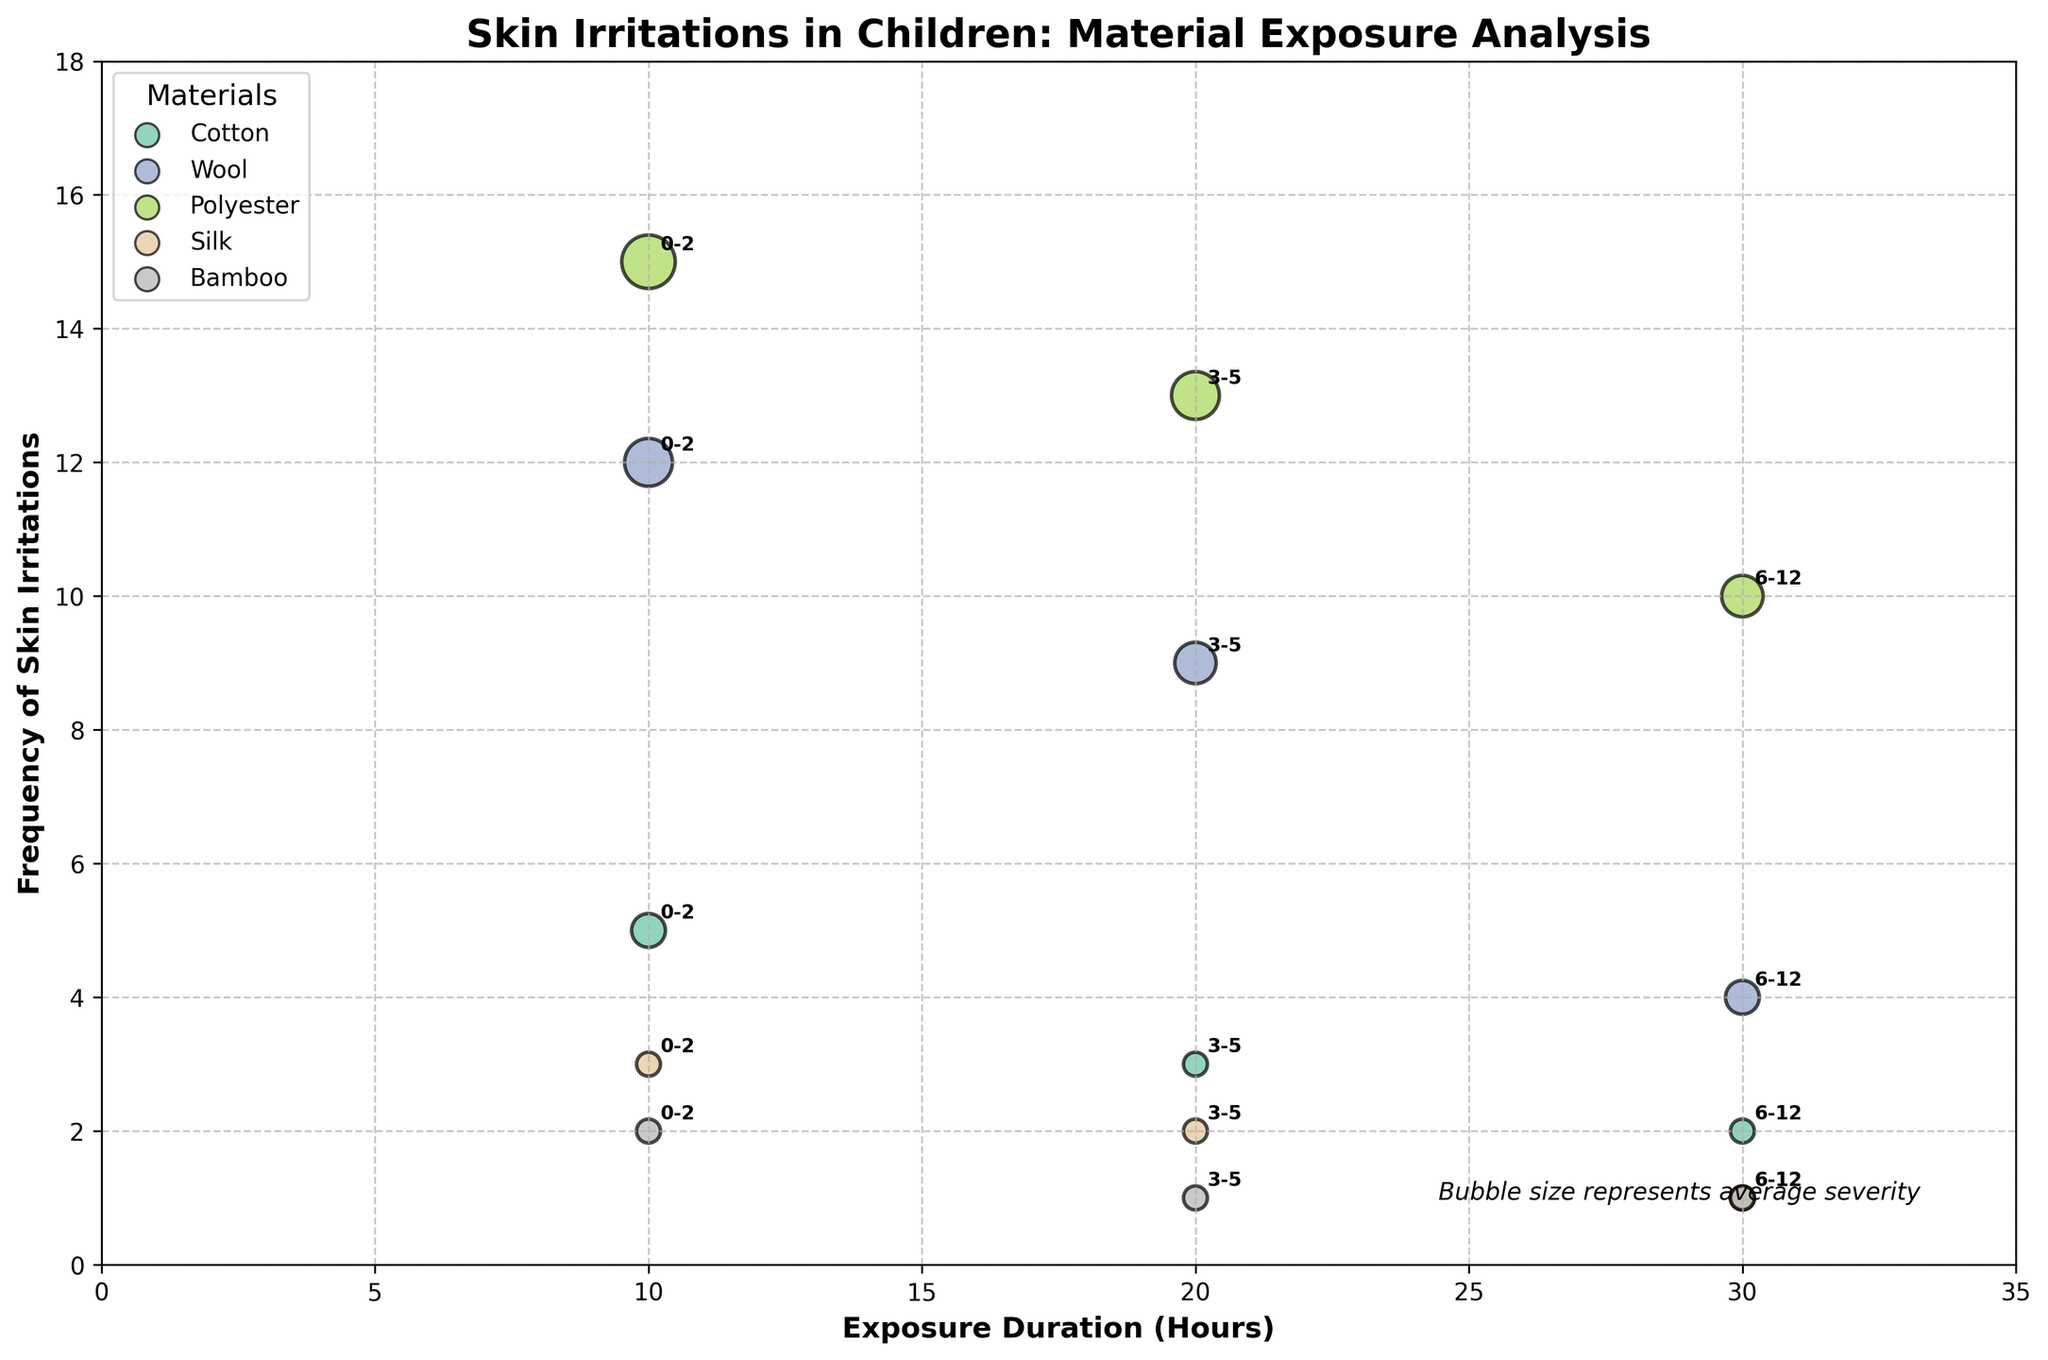What is the age group with the highest frequency of skin irritations for cotton material? To find this, look for the data points representing cotton material and identify the age group that corresponds to the highest value on the y-axis (frequency of skin irritations). The highest frequency for cotton is at the age group 0-2.
Answer: 0-2 How does the frequency of skin irritations caused by polyester compare between the age groups 0-2 and 6-12? Identify the data points for polyester material, specifically for age groups 0-2 and 6-12. Compare their y-axis values (frequency of skin irritations). The frequency for age group 0-2 is 15, and for 6-12 it is 10. Therefore, 0-2 has a higher frequency.
Answer: Higher in 0-2 What is the average severity of skin irritations for silk material across all age groups? Locate all data points for silk material and note their average severity (bubble size). The values are 1, 1, and 1. To find the average severity, sum these values and divide by the number of age groups: (1+1+1)/3 = 1.
Answer: 1 Which material is associated with the lowest frequency of skin irritations for the age group 3-5? Find the data points corresponding to the age group 3-5 and compare their y-axis values (frequency of skin irritations). Look for the smallest value. The smallest frequency for age group 3-5 is 1, associated with bamboo and silk.
Answer: Bamboo and silk Is exposure duration related to the frequency of skin irritations for wool material? Analyze the data points for wool material and observe the trend in frequency (y-axis) as the exposure duration (x-axis) increases. The frequency decreases as exposure duration increases from 10 to 30 hours (12, 9, and 4), implying a negative correlation.
Answer: Negative correlation For which material does the frequency of skin irritations decrease as children age from 0-2 to 6-12? Check if the y-axis values (frequency of skin irritations) decrease as the age group changes from 0-2 to 6-12 for each material. Materials where this happens are cotton, wool, polyester, silk, and bamboo, but the question asks in singular. The data provided indicates a clear downward trend in cotton.
Answer: Cotton Which material has the largest bubble size and what does it represent? The largest bubble indicates the highest average severity. Locate the material with the largest scatter bubble. For polyester, the bubble sizes are 5 for 0-2 age group, representing the highest average severity.
Answer: Polyester What exposure duration results in the highest frequency of skin irritations in children aged 3-5 for wool material? Identify the data points for wool material and note those corresponding to the age group 3-5. Compare their x-axis values (exposure duration) and determine the highest y-axis value. The highest frequency of 9 occurs at 20 hours.
Answer: 20 hours 